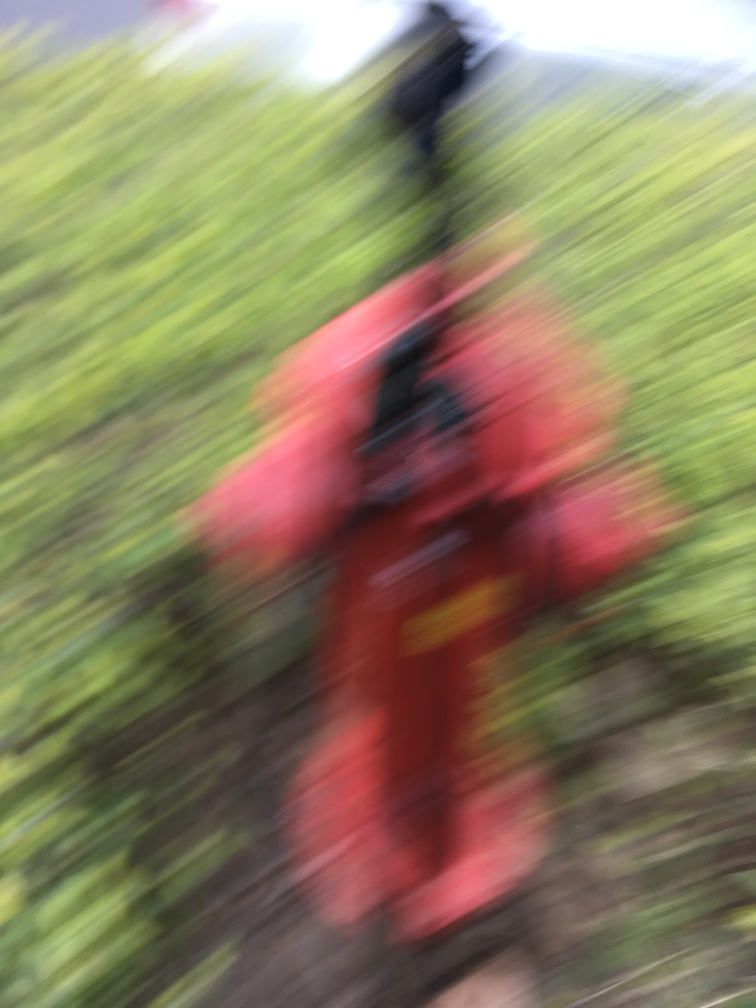What might have caused the blurriness in this photo? The blurriness in the photo could be due to several factors, such as camera movement during the shot, a slow shutter speed in low light conditions, or an out-of-focus lens. It is also possible that the photographer might have intended to create an artistic effect by moving the camera while taking the picture. 